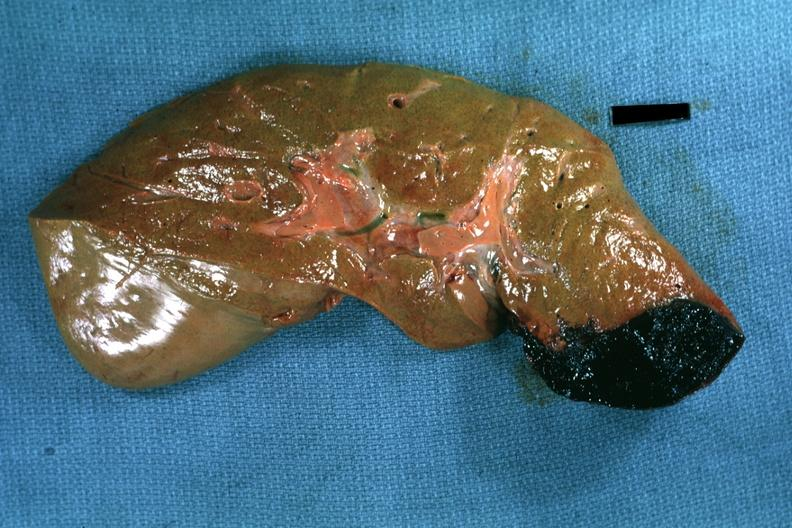s liver present?
Answer the question using a single word or phrase. Yes 